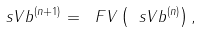<formula> <loc_0><loc_0><loc_500><loc_500>\ s V b ^ { ( n + 1 ) } = \ F V \left ( \ s V b ^ { ( n ) } \right ) ,</formula> 